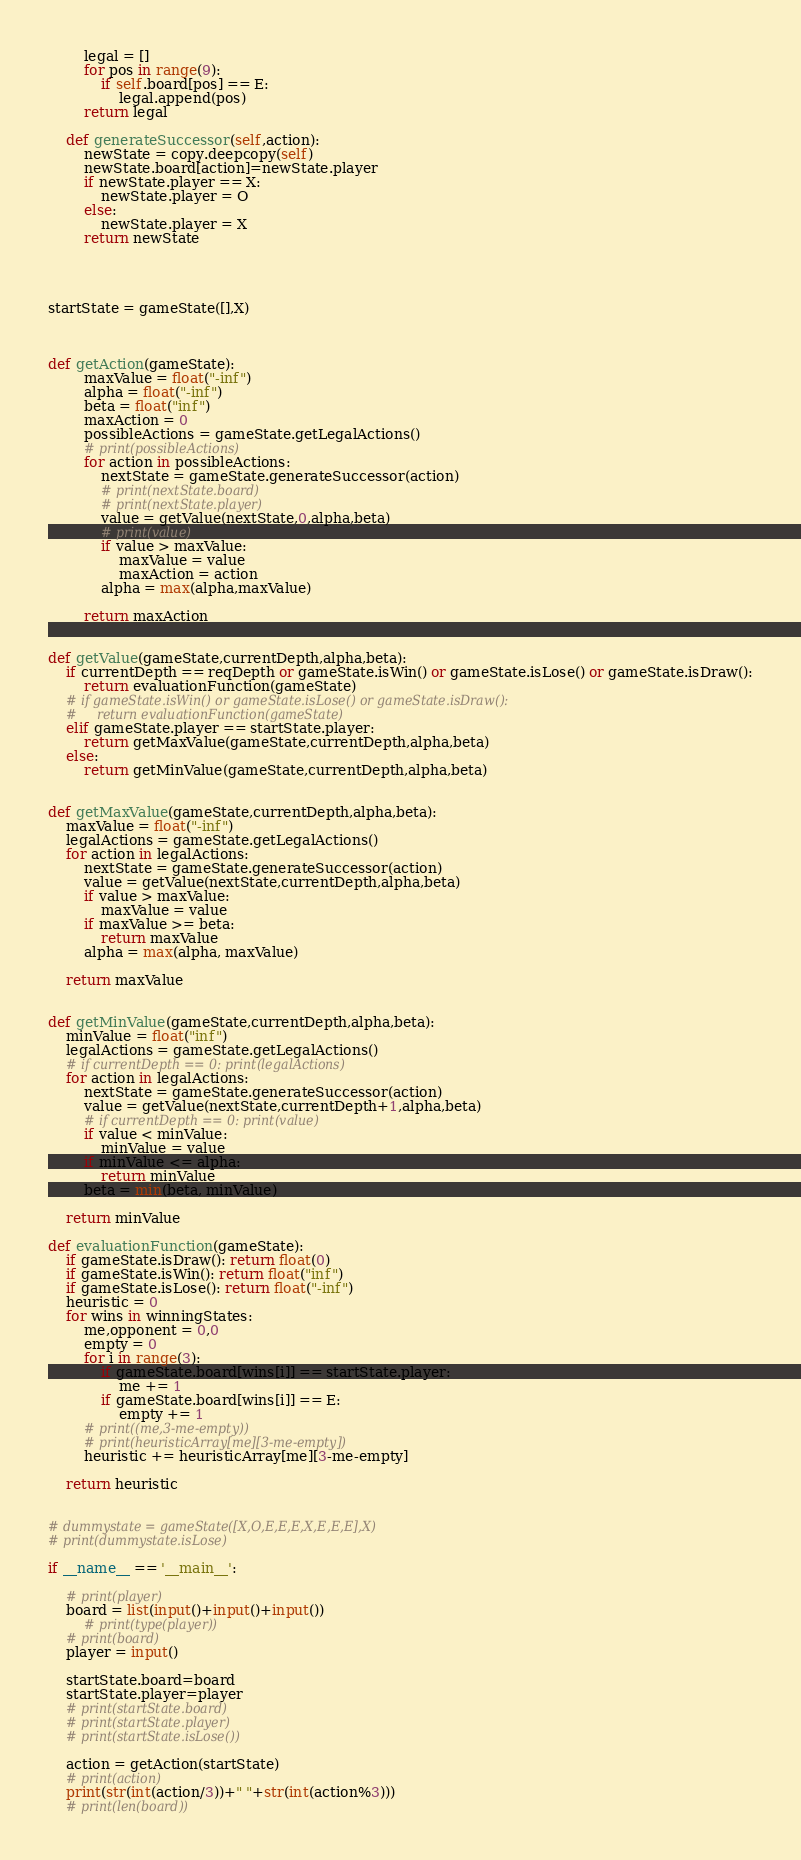<code> <loc_0><loc_0><loc_500><loc_500><_Python_>        legal = []
        for pos in range(9):
            if self.board[pos] == E:
                legal.append(pos)
        return legal

    def generateSuccessor(self,action):
        newState = copy.deepcopy(self)
        newState.board[action]=newState.player
        if newState.player == X:
            newState.player = O
        else:
            newState.player = X
        return newState




startState = gameState([],X)



def getAction(gameState):
        maxValue = float("-inf")
        alpha = float("-inf")
        beta = float("inf")
        maxAction = 0
        possibleActions = gameState.getLegalActions()
        # print(possibleActions)
        for action in possibleActions:
            nextState = gameState.generateSuccessor(action)
            # print(nextState.board)
            # print(nextState.player)
            value = getValue(nextState,0,alpha,beta)
            # print(value)
            if value > maxValue:
                maxValue = value
                maxAction = action
            alpha = max(alpha,maxValue)

        return maxAction


def getValue(gameState,currentDepth,alpha,beta):
    if currentDepth == reqDepth or gameState.isWin() or gameState.isLose() or gameState.isDraw():
        return evaluationFunction(gameState)
    # if gameState.isWin() or gameState.isLose() or gameState.isDraw():
    #     return evaluationFunction(gameState)
    elif gameState.player == startState.player:
        return getMaxValue(gameState,currentDepth,alpha,beta)
    else:
        return getMinValue(gameState,currentDepth,alpha,beta)


def getMaxValue(gameState,currentDepth,alpha,beta):
    maxValue = float("-inf")
    legalActions = gameState.getLegalActions()
    for action in legalActions:
        nextState = gameState.generateSuccessor(action)
        value = getValue(nextState,currentDepth,alpha,beta)
        if value > maxValue:
            maxValue = value
        if maxValue >= beta:
            return maxValue
        alpha = max(alpha, maxValue)

    return maxValue


def getMinValue(gameState,currentDepth,alpha,beta):
    minValue = float("inf")
    legalActions = gameState.getLegalActions()
    # if currentDepth == 0: print(legalActions)
    for action in legalActions:
        nextState = gameState.generateSuccessor(action)
        value = getValue(nextState,currentDepth+1,alpha,beta)
        # if currentDepth == 0: print(value)
        if value < minValue:
            minValue = value
        if minValue <= alpha:
            return minValue
        beta = min(beta, minValue)

    return minValue

def evaluationFunction(gameState):
    if gameState.isDraw(): return float(0)
    if gameState.isWin(): return float("inf")
    if gameState.isLose(): return float("-inf")
    heuristic = 0
    for wins in winningStates:
        me,opponent = 0,0
        empty = 0
        for i in range(3):
            if gameState.board[wins[i]] == startState.player:
                me += 1
            if gameState.board[wins[i]] == E:
                empty += 1
        # print((me,3-me-empty))
        # print(heuristicArray[me][3-me-empty])
        heuristic += heuristicArray[me][3-me-empty]

    return heuristic


# dummystate = gameState([X,O,E,E,E,X,E,E,E],X)
# print(dummystate.isLose)

if __name__ == '__main__':

    # print(player)
    board = list(input()+input()+input())
        # print(type(player))
    # print(board)
    player = input()

    startState.board=board
    startState.player=player
    # print(startState.board)
    # print(startState.player)
    # print(startState.isLose())

    action = getAction(startState)
    # print(action)
    print(str(int(action/3))+" "+str(int(action%3)))
    # print(len(board))
</code> 